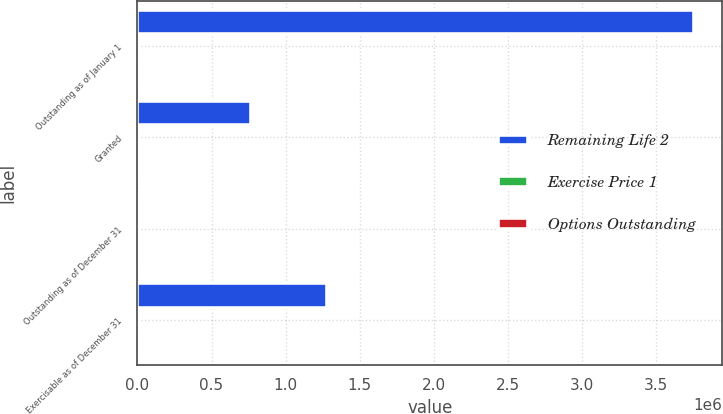Convert chart to OTSL. <chart><loc_0><loc_0><loc_500><loc_500><stacked_bar_chart><ecel><fcel>Outstanding as of January 1<fcel>Granted<fcel>Outstanding as of December 31<fcel>Exercisable as of December 31<nl><fcel>Remaining Life 2<fcel>3.75795e+06<fcel>764789<fcel>47<fcel>1.2805e+06<nl><fcel>Exercise Price 1<fcel>46.81<fcel>47<fcel>48.28<fcel>50.07<nl><fcel>Options Outstanding<fcel>5.85<fcel>9<fcel>5.89<fcel>3.78<nl></chart> 